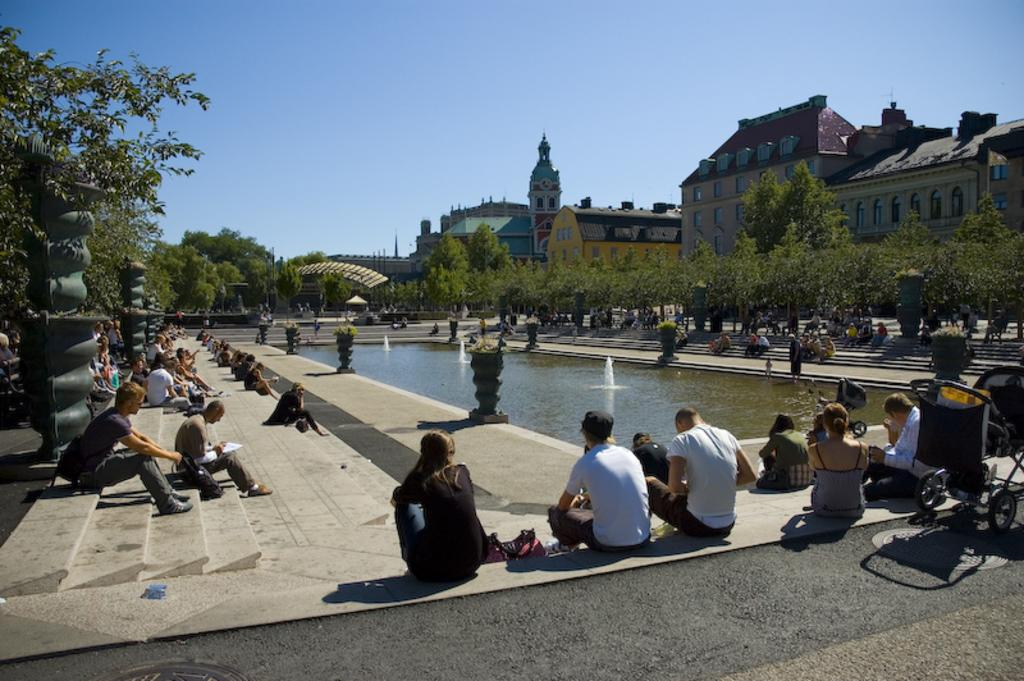What are the people in the image doing? The people in the image are sitting on steps. What is the main feature in the middle of the image? There is a fountain in the middle of the image. What can be seen around the fountain? There are trees around the fountain. What structures can be seen in the image? There are buildings visible in the image. What is visible in the background of the image? The sky is visible in the background of the image. What rule is being enforced by the rod in the image? There is no rod present in the image, and therefore no rule is being enforced. What position does the person sitting on the steps hold in the image? The image does not provide information about the positions or roles of the people sitting on the steps. 